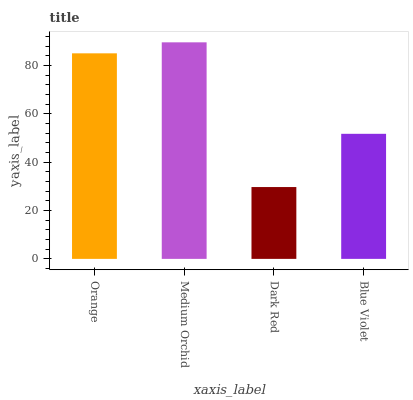Is Dark Red the minimum?
Answer yes or no. Yes. Is Medium Orchid the maximum?
Answer yes or no. Yes. Is Medium Orchid the minimum?
Answer yes or no. No. Is Dark Red the maximum?
Answer yes or no. No. Is Medium Orchid greater than Dark Red?
Answer yes or no. Yes. Is Dark Red less than Medium Orchid?
Answer yes or no. Yes. Is Dark Red greater than Medium Orchid?
Answer yes or no. No. Is Medium Orchid less than Dark Red?
Answer yes or no. No. Is Orange the high median?
Answer yes or no. Yes. Is Blue Violet the low median?
Answer yes or no. Yes. Is Medium Orchid the high median?
Answer yes or no. No. Is Orange the low median?
Answer yes or no. No. 